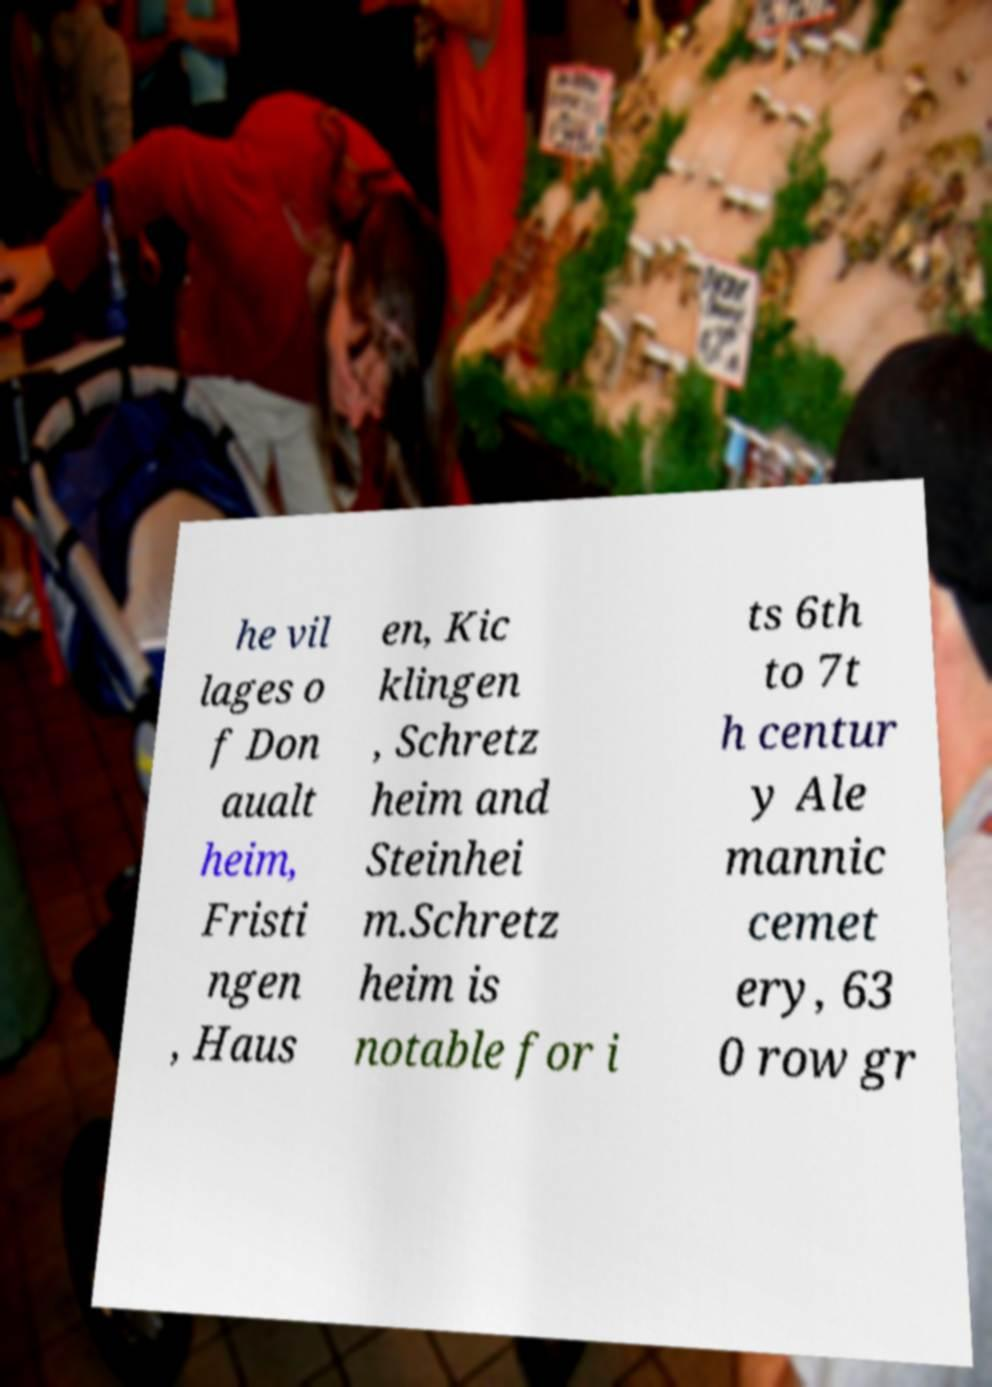Please read and relay the text visible in this image. What does it say? he vil lages o f Don aualt heim, Fristi ngen , Haus en, Kic klingen , Schretz heim and Steinhei m.Schretz heim is notable for i ts 6th to 7t h centur y Ale mannic cemet ery, 63 0 row gr 